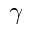Convert formula to latex. <formula><loc_0><loc_0><loc_500><loc_500>\gamma</formula> 